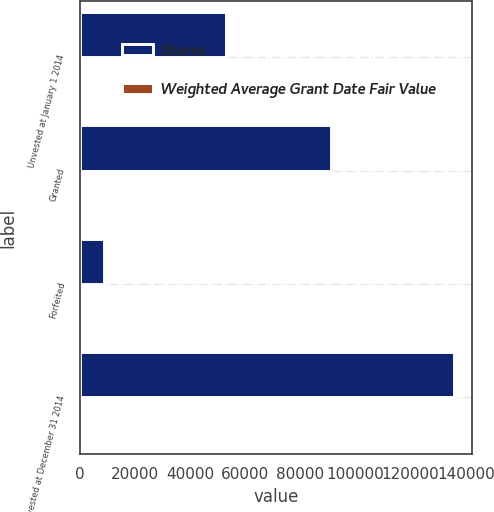Convert chart to OTSL. <chart><loc_0><loc_0><loc_500><loc_500><stacked_bar_chart><ecel><fcel>Unvested at January 1 2014<fcel>Granted<fcel>Forfeited<fcel>Unvested at December 31 2014<nl><fcel>Shares<fcel>53205<fcel>91030<fcel>8695<fcel>135540<nl><fcel>Weighted Average Grant Date Fair Value<fcel>59.98<fcel>94.55<fcel>78.26<fcel>81.87<nl></chart> 